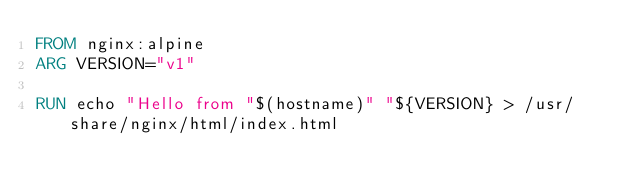Convert code to text. <code><loc_0><loc_0><loc_500><loc_500><_Dockerfile_>FROM nginx:alpine
ARG VERSION="v1"

RUN echo "Hello from "$(hostname)" "${VERSION} > /usr/share/nginx/html/index.html
</code> 